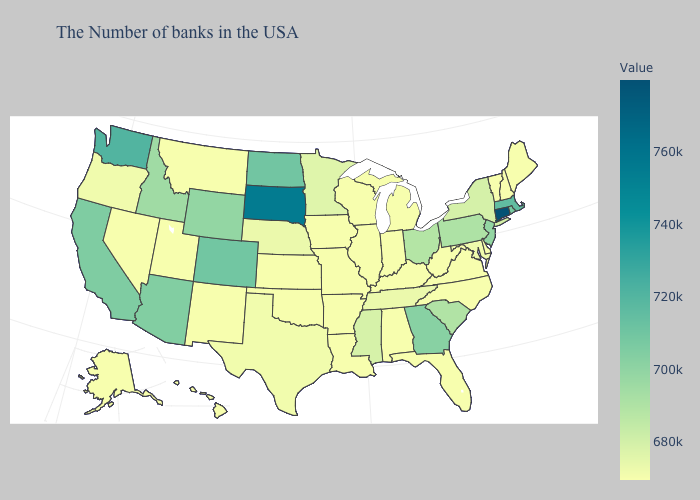Is the legend a continuous bar?
Short answer required. Yes. Does the map have missing data?
Give a very brief answer. No. Among the states that border Massachusetts , does Connecticut have the lowest value?
Concise answer only. No. Does Colorado have a higher value than Iowa?
Write a very short answer. Yes. Which states have the lowest value in the Northeast?
Write a very short answer. Maine, New Hampshire, Vermont. 